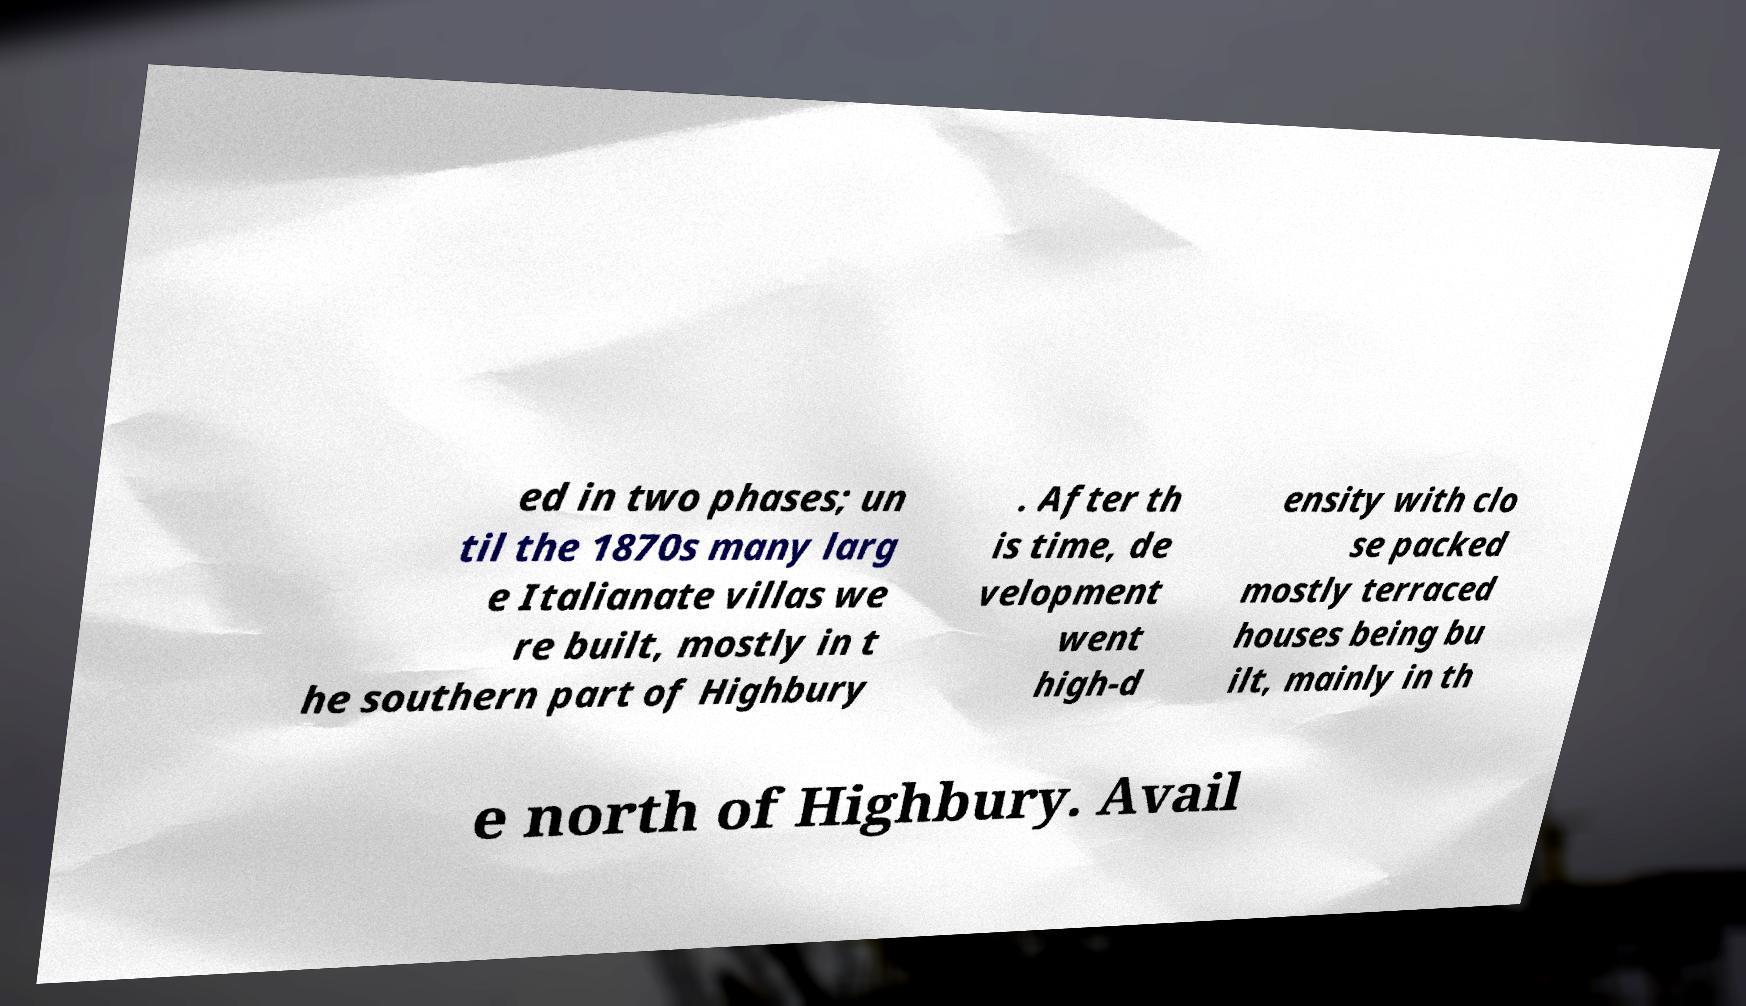I need the written content from this picture converted into text. Can you do that? ed in two phases; un til the 1870s many larg e Italianate villas we re built, mostly in t he southern part of Highbury . After th is time, de velopment went high-d ensity with clo se packed mostly terraced houses being bu ilt, mainly in th e north of Highbury. Avail 